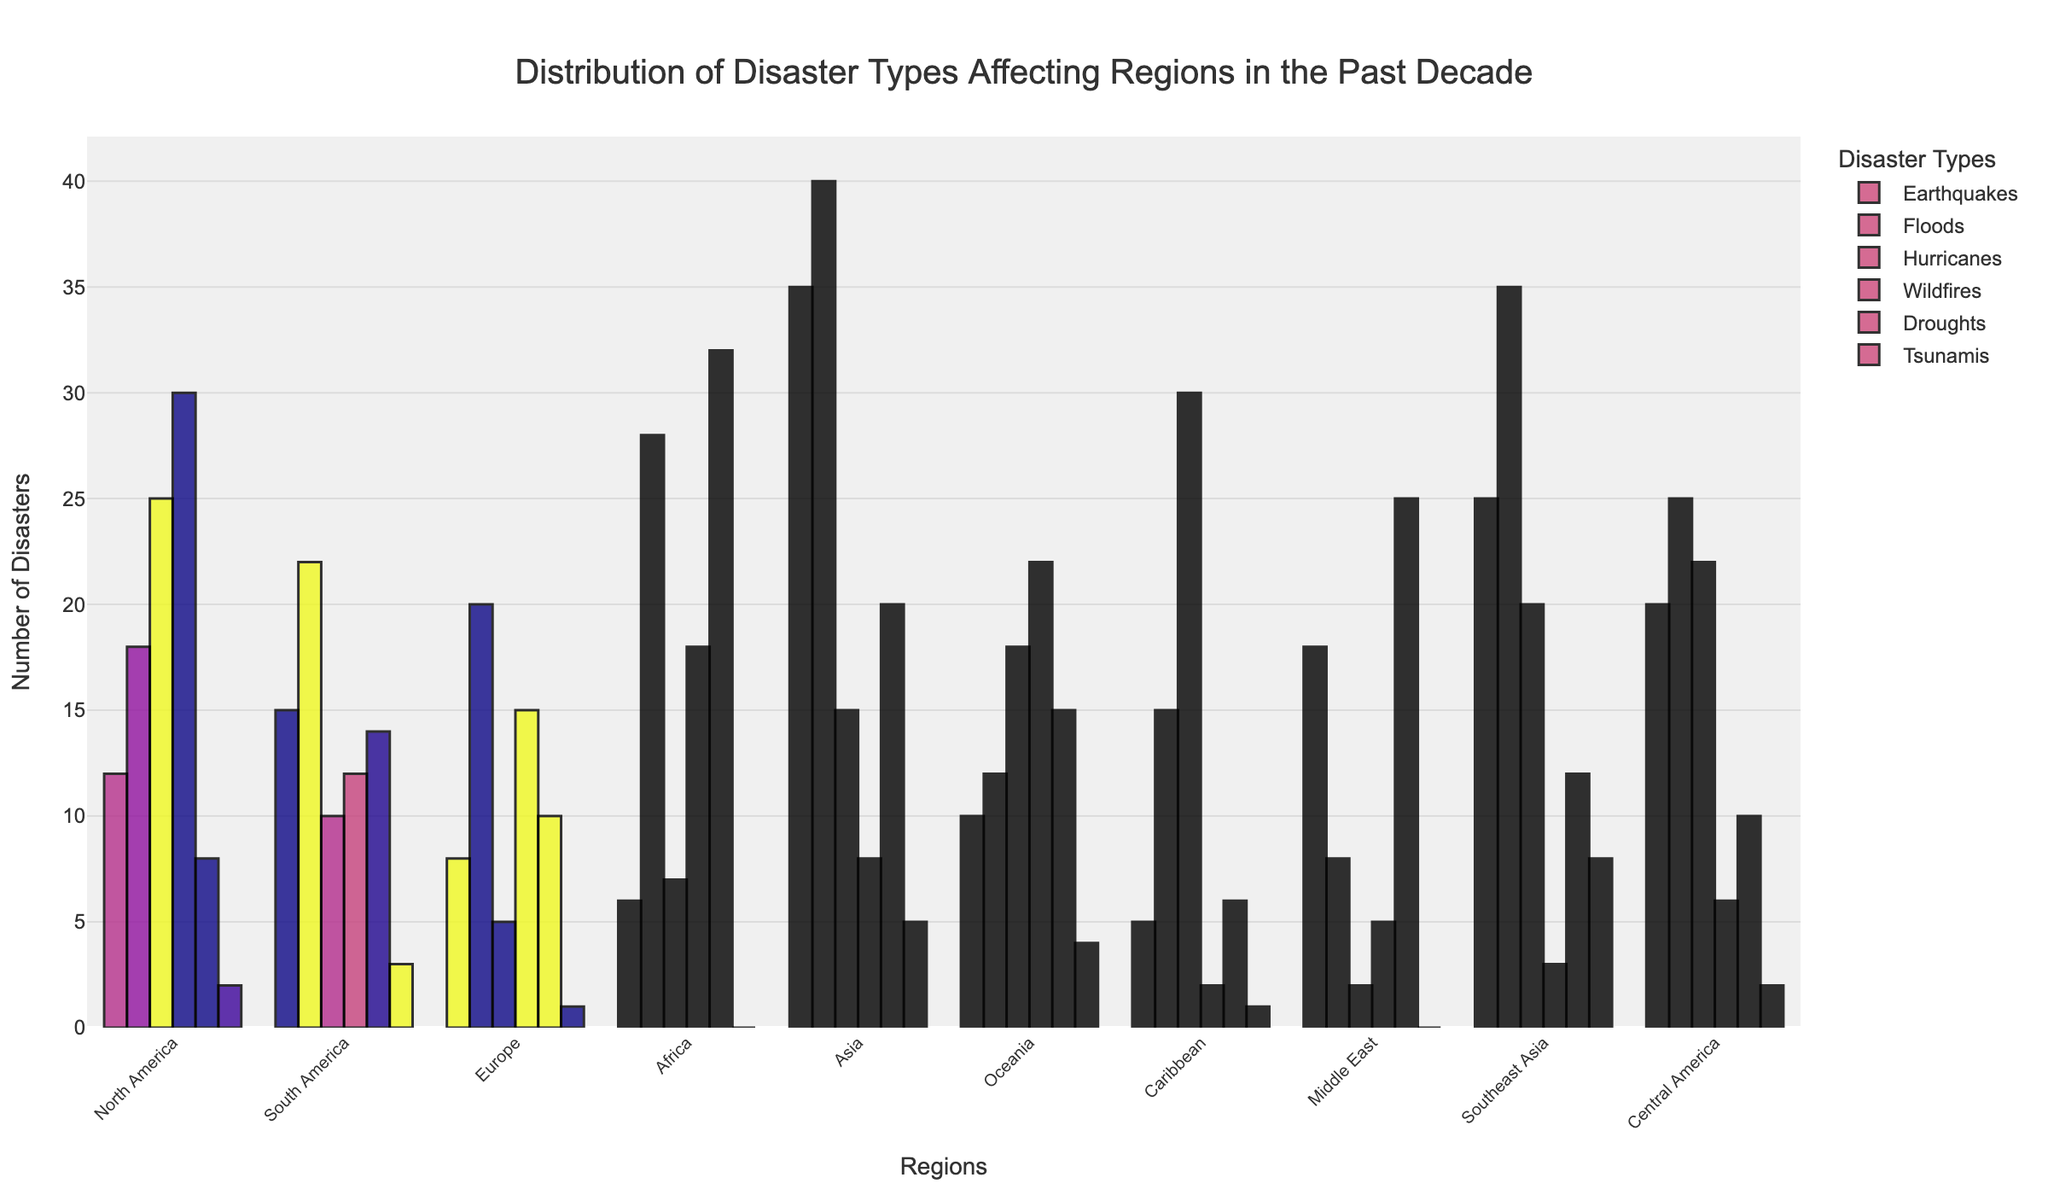What region experienced the highest number of wildfires? To find the region with the highest number of wildfires, look at the bar corresponding to wildfires for each region and compare their heights. The tallest bar represents the highest frequency. North America's bar is the tallest for wildfires.
Answer: North America Which disaster type had the least occurrences in Africa? To find the disaster type with the least occurrences in Africa, compare all bars representing different disaster types for Africa. The shortest bar corresponds to the least occurrences, which is Tsunamis with 0 occurrences.
Answer: Tsunamis How many more floods than hurricanes were there in Asia? First, find the number of floods (40) and hurricanes (15) in Asia. Subtract the number of hurricanes from the number of floods: 40 - 15 = 25.
Answer: 25 Which region experienced the most tsunamis? Look at the bars corresponding to tsunamis for each region and identify the tallest one. Southeast Asia has the tallest bar for tsunamis.
Answer: Southeast Asia What is the total number of earthquakes in North America and the Middle East? Add the number of earthquakes in North America (12) to the number in the Middle East (18): 12 + 18 = 30.
Answer: 30 How does the number of droughts in Africa compare to those in Europe? Look at the bars corresponding to droughts for Africa and Europe, then compare their heights. Africa has a taller bar (32) than Europe (10), indicating more droughts in Africa.
Answer: Africa has more droughts than Europe What's the average number of hurricanes in Caribbean, Central America, and Oceania? To find the average, first add the number of hurricanes in the Caribbean (30), Central America (22), and Oceania (18): 30 + 22 + 18 = 70. Then, divide by the number of regions (3): 70 / 3 ≈ 23.33.
Answer: 23.33 In which region is the occurrence of droughts higher than the occurrence of floods? Compare droughts and floods for each region. Africa (28 floods, 32 droughts) and Middle East (8 floods, 25 droughts) both have higher occurrences of droughts than floods.
Answer: Africa and Middle East How many regions experienced more than 20 floods? Count the regions where the bar for floods crosses the 20 mark. The regions are South America (22), Asia (40), Southeast Asia (35), and Central America (25), totaling four regions.
Answer: 4 